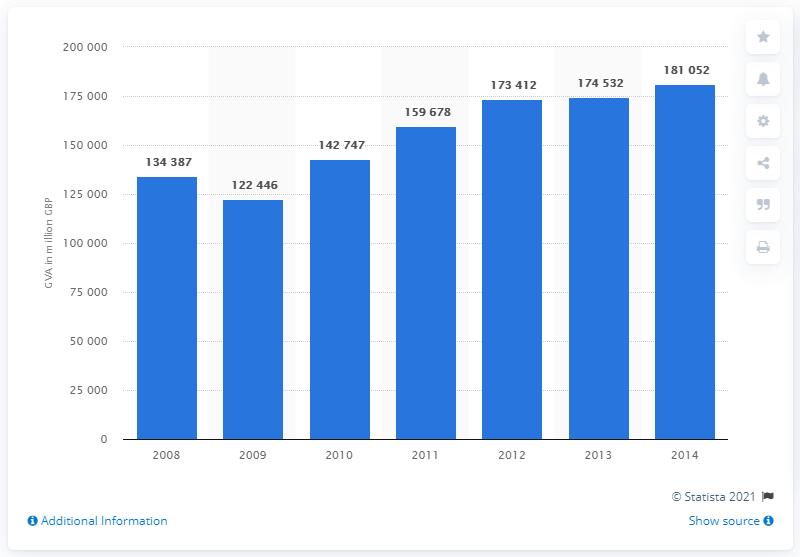Draw attention to some important aspects in this diagram. In the year 2009, the Gross Value Added (GVA) of the real estate sector fell. 